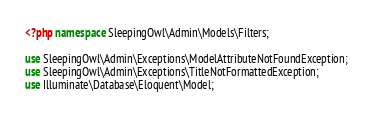<code> <loc_0><loc_0><loc_500><loc_500><_PHP_><?php namespace SleepingOwl\Admin\Models\Filters;

use SleepingOwl\Admin\Exceptions\ModelAttributeNotFoundException;
use SleepingOwl\Admin\Exceptions\TitleNotFormattedException;
use Illuminate\Database\Eloquent\Model;</code> 